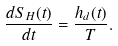<formula> <loc_0><loc_0><loc_500><loc_500>\frac { d S _ { H } ( t ) } { d t } = \frac { h _ { d } ( t ) } { T } .</formula> 